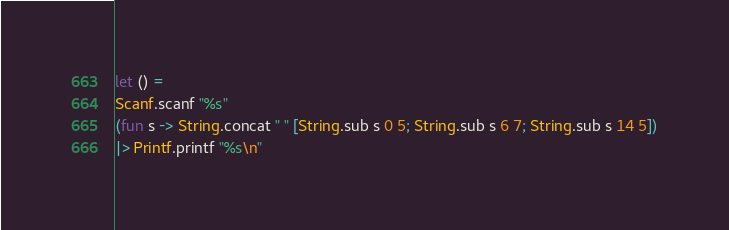<code> <loc_0><loc_0><loc_500><loc_500><_OCaml_>let () =
Scanf.scanf "%s"
(fun s -> String.concat " " [String.sub s 0 5; String.sub s 6 7; String.sub s 14 5])
|> Printf.printf "%s\n"</code> 